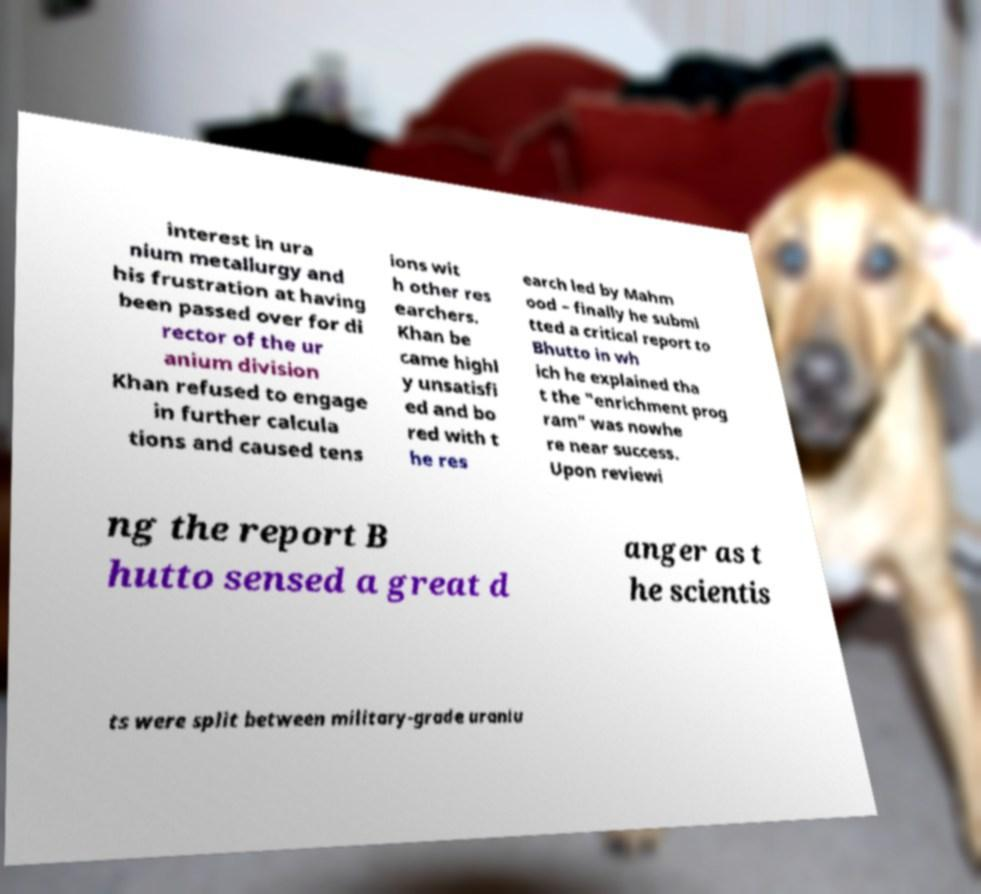For documentation purposes, I need the text within this image transcribed. Could you provide that? interest in ura nium metallurgy and his frustration at having been passed over for di rector of the ur anium division Khan refused to engage in further calcula tions and caused tens ions wit h other res earchers. Khan be came highl y unsatisfi ed and bo red with t he res earch led by Mahm ood – finally he submi tted a critical report to Bhutto in wh ich he explained tha t the "enrichment prog ram" was nowhe re near success. Upon reviewi ng the report B hutto sensed a great d anger as t he scientis ts were split between military-grade uraniu 